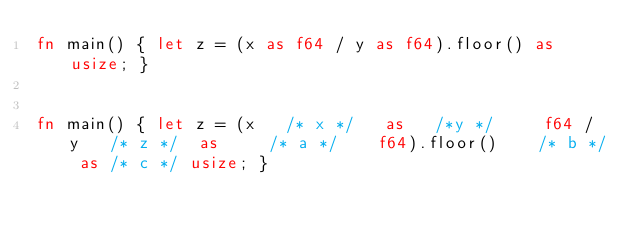Convert code to text. <code><loc_0><loc_0><loc_500><loc_500><_Rust_>fn main() { let z = (x as f64 / y as f64).floor() as usize; }


fn main() { let z = (x   /* x */   as   /*y */     f64 / y   /* z */  as     /* a */    f64).floor()    /* b */ as /* c */ usize; }</code> 